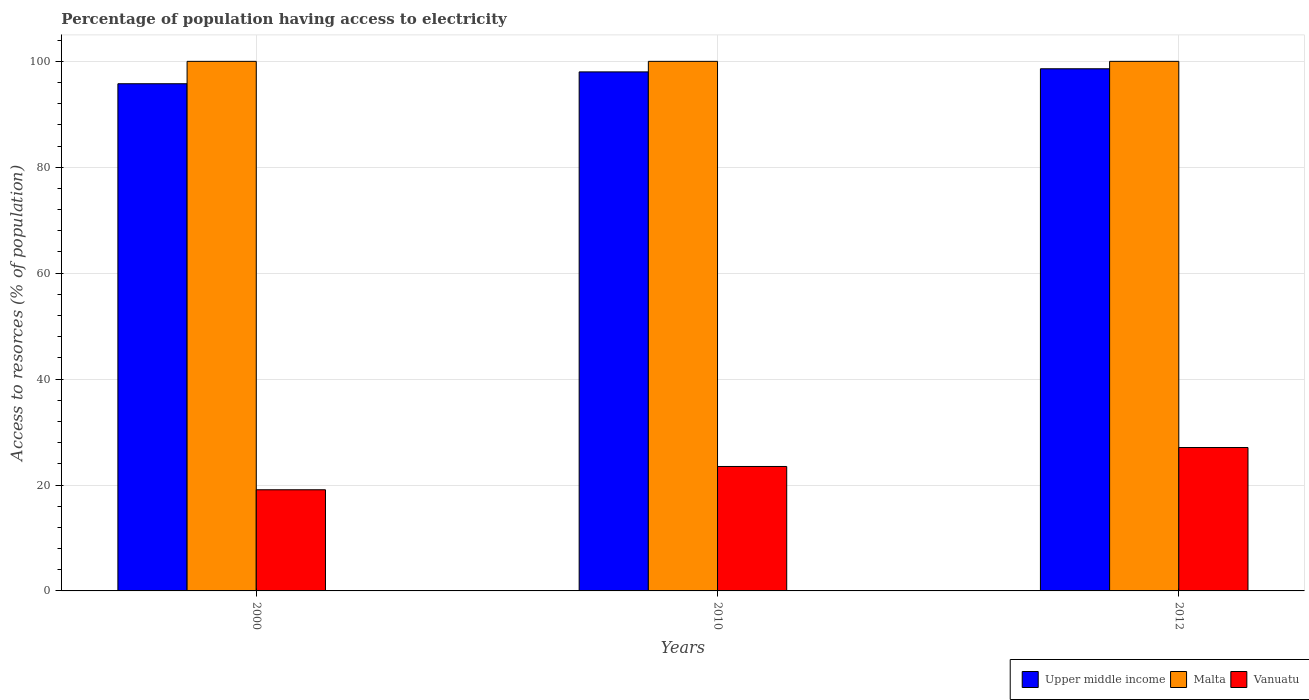How many different coloured bars are there?
Provide a short and direct response. 3. How many groups of bars are there?
Your answer should be very brief. 3. Are the number of bars on each tick of the X-axis equal?
Your answer should be compact. Yes. How many bars are there on the 1st tick from the left?
Keep it short and to the point. 3. How many bars are there on the 3rd tick from the right?
Your answer should be very brief. 3. What is the percentage of population having access to electricity in Upper middle income in 2010?
Offer a terse response. 98.01. Across all years, what is the maximum percentage of population having access to electricity in Vanuatu?
Offer a very short reply. 27.08. Across all years, what is the minimum percentage of population having access to electricity in Vanuatu?
Provide a short and direct response. 19.1. In which year was the percentage of population having access to electricity in Malta maximum?
Ensure brevity in your answer.  2000. In which year was the percentage of population having access to electricity in Malta minimum?
Offer a very short reply. 2000. What is the total percentage of population having access to electricity in Malta in the graph?
Ensure brevity in your answer.  300. What is the difference between the percentage of population having access to electricity in Upper middle income in 2010 and that in 2012?
Provide a succinct answer. -0.59. What is the difference between the percentage of population having access to electricity in Vanuatu in 2010 and the percentage of population having access to electricity in Malta in 2012?
Your answer should be very brief. -76.5. What is the average percentage of population having access to electricity in Upper middle income per year?
Keep it short and to the point. 97.46. In the year 2012, what is the difference between the percentage of population having access to electricity in Vanuatu and percentage of population having access to electricity in Malta?
Give a very brief answer. -72.92. What is the ratio of the percentage of population having access to electricity in Upper middle income in 2010 to that in 2012?
Ensure brevity in your answer.  0.99. What is the difference between the highest and the second highest percentage of population having access to electricity in Vanuatu?
Provide a short and direct response. 3.58. What is the difference between the highest and the lowest percentage of population having access to electricity in Vanuatu?
Make the answer very short. 7.98. In how many years, is the percentage of population having access to electricity in Malta greater than the average percentage of population having access to electricity in Malta taken over all years?
Your answer should be very brief. 0. What does the 2nd bar from the left in 2010 represents?
Your answer should be very brief. Malta. What does the 3rd bar from the right in 2010 represents?
Your answer should be very brief. Upper middle income. Is it the case that in every year, the sum of the percentage of population having access to electricity in Upper middle income and percentage of population having access to electricity in Vanuatu is greater than the percentage of population having access to electricity in Malta?
Make the answer very short. Yes. How many bars are there?
Give a very brief answer. 9. Are all the bars in the graph horizontal?
Provide a short and direct response. No. What is the difference between two consecutive major ticks on the Y-axis?
Make the answer very short. 20. How many legend labels are there?
Ensure brevity in your answer.  3. How are the legend labels stacked?
Provide a short and direct response. Horizontal. What is the title of the graph?
Your answer should be very brief. Percentage of population having access to electricity. Does "Iraq" appear as one of the legend labels in the graph?
Ensure brevity in your answer.  No. What is the label or title of the Y-axis?
Your answer should be compact. Access to resorces (% of population). What is the Access to resorces (% of population) of Upper middle income in 2000?
Make the answer very short. 95.77. What is the Access to resorces (% of population) of Malta in 2000?
Make the answer very short. 100. What is the Access to resorces (% of population) in Vanuatu in 2000?
Your answer should be compact. 19.1. What is the Access to resorces (% of population) of Upper middle income in 2010?
Provide a short and direct response. 98.01. What is the Access to resorces (% of population) in Malta in 2010?
Make the answer very short. 100. What is the Access to resorces (% of population) in Upper middle income in 2012?
Offer a terse response. 98.6. What is the Access to resorces (% of population) in Malta in 2012?
Make the answer very short. 100. What is the Access to resorces (% of population) of Vanuatu in 2012?
Provide a succinct answer. 27.08. Across all years, what is the maximum Access to resorces (% of population) in Upper middle income?
Offer a terse response. 98.6. Across all years, what is the maximum Access to resorces (% of population) in Vanuatu?
Your answer should be compact. 27.08. Across all years, what is the minimum Access to resorces (% of population) of Upper middle income?
Ensure brevity in your answer.  95.77. What is the total Access to resorces (% of population) of Upper middle income in the graph?
Your answer should be very brief. 292.38. What is the total Access to resorces (% of population) of Malta in the graph?
Offer a very short reply. 300. What is the total Access to resorces (% of population) of Vanuatu in the graph?
Your answer should be very brief. 69.68. What is the difference between the Access to resorces (% of population) of Upper middle income in 2000 and that in 2010?
Ensure brevity in your answer.  -2.24. What is the difference between the Access to resorces (% of population) in Malta in 2000 and that in 2010?
Ensure brevity in your answer.  0. What is the difference between the Access to resorces (% of population) of Upper middle income in 2000 and that in 2012?
Your response must be concise. -2.83. What is the difference between the Access to resorces (% of population) of Malta in 2000 and that in 2012?
Offer a terse response. 0. What is the difference between the Access to resorces (% of population) in Vanuatu in 2000 and that in 2012?
Your response must be concise. -7.98. What is the difference between the Access to resorces (% of population) in Upper middle income in 2010 and that in 2012?
Ensure brevity in your answer.  -0.59. What is the difference between the Access to resorces (% of population) of Malta in 2010 and that in 2012?
Offer a very short reply. 0. What is the difference between the Access to resorces (% of population) of Vanuatu in 2010 and that in 2012?
Make the answer very short. -3.58. What is the difference between the Access to resorces (% of population) in Upper middle income in 2000 and the Access to resorces (% of population) in Malta in 2010?
Offer a very short reply. -4.23. What is the difference between the Access to resorces (% of population) in Upper middle income in 2000 and the Access to resorces (% of population) in Vanuatu in 2010?
Keep it short and to the point. 72.27. What is the difference between the Access to resorces (% of population) in Malta in 2000 and the Access to resorces (% of population) in Vanuatu in 2010?
Make the answer very short. 76.5. What is the difference between the Access to resorces (% of population) in Upper middle income in 2000 and the Access to resorces (% of population) in Malta in 2012?
Provide a short and direct response. -4.23. What is the difference between the Access to resorces (% of population) in Upper middle income in 2000 and the Access to resorces (% of population) in Vanuatu in 2012?
Keep it short and to the point. 68.69. What is the difference between the Access to resorces (% of population) of Malta in 2000 and the Access to resorces (% of population) of Vanuatu in 2012?
Your response must be concise. 72.92. What is the difference between the Access to resorces (% of population) of Upper middle income in 2010 and the Access to resorces (% of population) of Malta in 2012?
Offer a terse response. -1.99. What is the difference between the Access to resorces (% of population) in Upper middle income in 2010 and the Access to resorces (% of population) in Vanuatu in 2012?
Give a very brief answer. 70.93. What is the difference between the Access to resorces (% of population) of Malta in 2010 and the Access to resorces (% of population) of Vanuatu in 2012?
Make the answer very short. 72.92. What is the average Access to resorces (% of population) of Upper middle income per year?
Ensure brevity in your answer.  97.46. What is the average Access to resorces (% of population) of Vanuatu per year?
Give a very brief answer. 23.23. In the year 2000, what is the difference between the Access to resorces (% of population) of Upper middle income and Access to resorces (% of population) of Malta?
Make the answer very short. -4.23. In the year 2000, what is the difference between the Access to resorces (% of population) in Upper middle income and Access to resorces (% of population) in Vanuatu?
Your answer should be very brief. 76.67. In the year 2000, what is the difference between the Access to resorces (% of population) in Malta and Access to resorces (% of population) in Vanuatu?
Provide a short and direct response. 80.9. In the year 2010, what is the difference between the Access to resorces (% of population) in Upper middle income and Access to resorces (% of population) in Malta?
Your answer should be compact. -1.99. In the year 2010, what is the difference between the Access to resorces (% of population) in Upper middle income and Access to resorces (% of population) in Vanuatu?
Keep it short and to the point. 74.51. In the year 2010, what is the difference between the Access to resorces (% of population) in Malta and Access to resorces (% of population) in Vanuatu?
Offer a terse response. 76.5. In the year 2012, what is the difference between the Access to resorces (% of population) in Upper middle income and Access to resorces (% of population) in Malta?
Provide a short and direct response. -1.4. In the year 2012, what is the difference between the Access to resorces (% of population) in Upper middle income and Access to resorces (% of population) in Vanuatu?
Give a very brief answer. 71.52. In the year 2012, what is the difference between the Access to resorces (% of population) in Malta and Access to resorces (% of population) in Vanuatu?
Keep it short and to the point. 72.92. What is the ratio of the Access to resorces (% of population) of Upper middle income in 2000 to that in 2010?
Provide a succinct answer. 0.98. What is the ratio of the Access to resorces (% of population) in Malta in 2000 to that in 2010?
Provide a succinct answer. 1. What is the ratio of the Access to resorces (% of population) of Vanuatu in 2000 to that in 2010?
Your answer should be compact. 0.81. What is the ratio of the Access to resorces (% of population) of Upper middle income in 2000 to that in 2012?
Offer a terse response. 0.97. What is the ratio of the Access to resorces (% of population) of Malta in 2000 to that in 2012?
Make the answer very short. 1. What is the ratio of the Access to resorces (% of population) of Vanuatu in 2000 to that in 2012?
Give a very brief answer. 0.71. What is the ratio of the Access to resorces (% of population) in Malta in 2010 to that in 2012?
Your answer should be compact. 1. What is the ratio of the Access to resorces (% of population) in Vanuatu in 2010 to that in 2012?
Provide a succinct answer. 0.87. What is the difference between the highest and the second highest Access to resorces (% of population) of Upper middle income?
Give a very brief answer. 0.59. What is the difference between the highest and the second highest Access to resorces (% of population) of Malta?
Offer a terse response. 0. What is the difference between the highest and the second highest Access to resorces (% of population) of Vanuatu?
Your response must be concise. 3.58. What is the difference between the highest and the lowest Access to resorces (% of population) in Upper middle income?
Provide a succinct answer. 2.83. What is the difference between the highest and the lowest Access to resorces (% of population) in Malta?
Make the answer very short. 0. What is the difference between the highest and the lowest Access to resorces (% of population) of Vanuatu?
Your answer should be very brief. 7.98. 